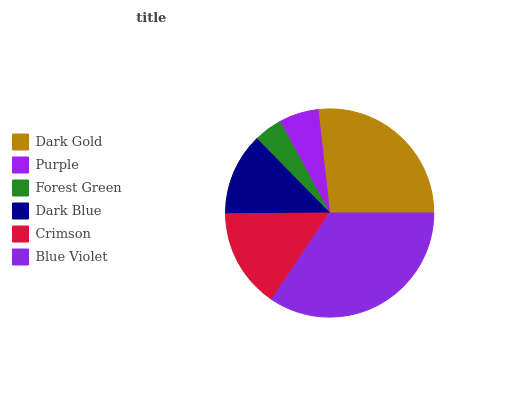Is Forest Green the minimum?
Answer yes or no. Yes. Is Blue Violet the maximum?
Answer yes or no. Yes. Is Purple the minimum?
Answer yes or no. No. Is Purple the maximum?
Answer yes or no. No. Is Dark Gold greater than Purple?
Answer yes or no. Yes. Is Purple less than Dark Gold?
Answer yes or no. Yes. Is Purple greater than Dark Gold?
Answer yes or no. No. Is Dark Gold less than Purple?
Answer yes or no. No. Is Crimson the high median?
Answer yes or no. Yes. Is Dark Blue the low median?
Answer yes or no. Yes. Is Blue Violet the high median?
Answer yes or no. No. Is Blue Violet the low median?
Answer yes or no. No. 